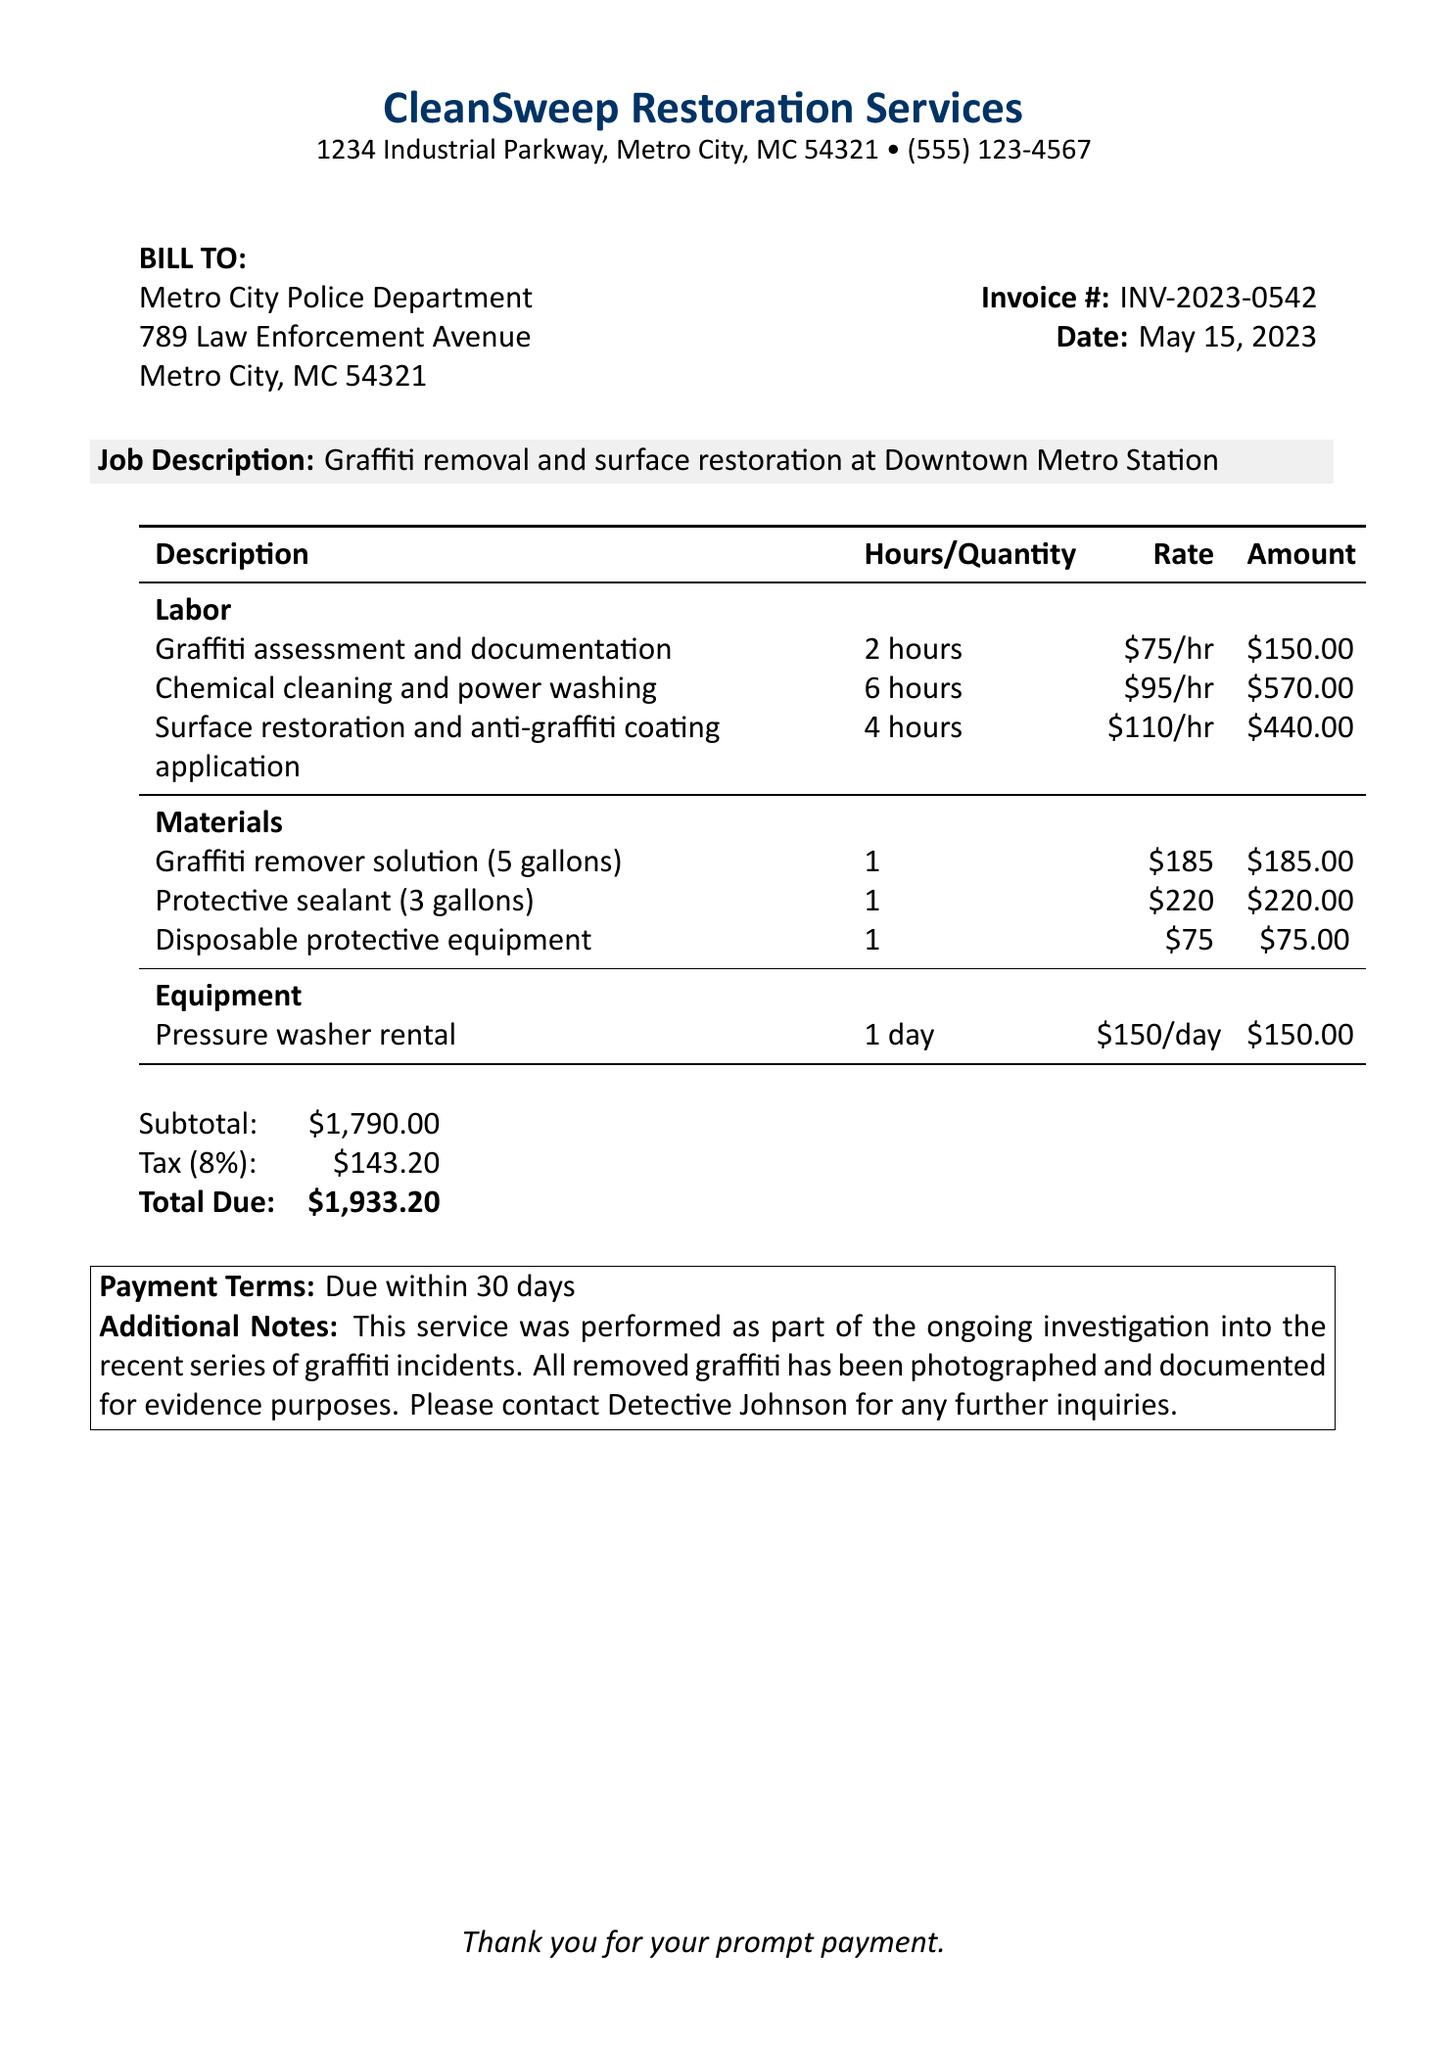What is the company name? The company name is listed at the top of the document, specifically as "CleanSweep Restoration Services."
Answer: CleanSweep Restoration Services What is the invoice number? The invoice number is provided in the document for reference, and it is "INV-2023-0542."
Answer: INV-2023-0542 What is the total due amount? The total due amount is found in the summary section, displayed as "$1,933.20."
Answer: $1,933.20 How many hours were spent on chemical cleaning and power washing? The document details the labor for cleaning, indicating that 6 hours were allocated to chemical cleaning and power washing.
Answer: 6 hours What is the tax rate applied? The tax rate is documented as 8% in the taxation details of the invoice.
Answer: 8% What materials were used for graffiti removal? The materials used include a graffiti remover solution, protective sealant, and disposable protective equipment, all listed in the materials section.
Answer: Graffiti remover solution, protective sealant, disposable protective equipment Who is the client in this invoice? The client is specified at the beginning of the document as "Metro City Police Department."
Answer: Metro City Police Department What additional notes are provided? Additional notes illustrate the purpose of the service performed and suggest contacting Detective Johnson for more inquiries.
Answer: Service performed as part of ongoing investigation; contact Detective Johnson 